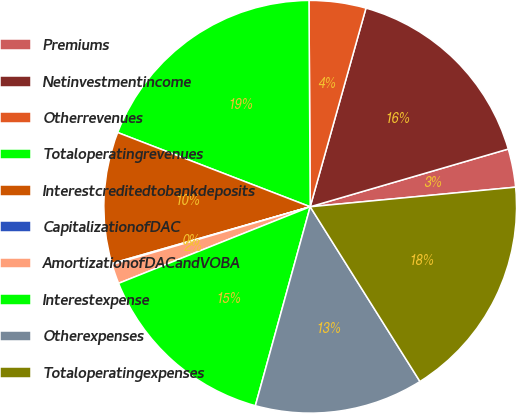Convert chart to OTSL. <chart><loc_0><loc_0><loc_500><loc_500><pie_chart><fcel>Premiums<fcel>Netinvestmentincome<fcel>Otherrevenues<fcel>Totaloperatingrevenues<fcel>Interestcreditedtobankdeposits<fcel>CapitalizationofDAC<fcel>AmortizationofDACandVOBA<fcel>Interestexpense<fcel>Otherexpenses<fcel>Totaloperatingexpenses<nl><fcel>3.0%<fcel>16.13%<fcel>4.45%<fcel>19.05%<fcel>10.29%<fcel>0.08%<fcel>1.54%<fcel>14.67%<fcel>13.21%<fcel>17.59%<nl></chart> 